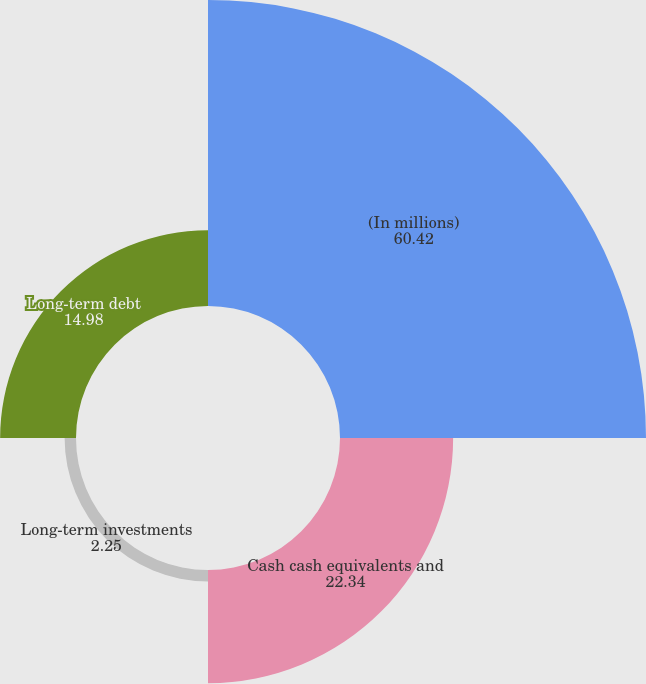Convert chart. <chart><loc_0><loc_0><loc_500><loc_500><pie_chart><fcel>(In millions)<fcel>Cash cash equivalents and<fcel>Long-term investments<fcel>Long-term debt<nl><fcel>60.42%<fcel>22.34%<fcel>2.25%<fcel>14.98%<nl></chart> 